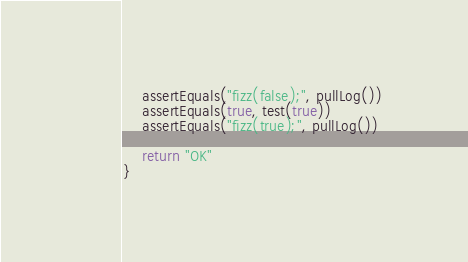Convert code to text. <code><loc_0><loc_0><loc_500><loc_500><_Kotlin_>    assertEquals("fizz(false);", pullLog())
    assertEquals(true, test(true))
    assertEquals("fizz(true);", pullLog())

    return "OK"
}</code> 